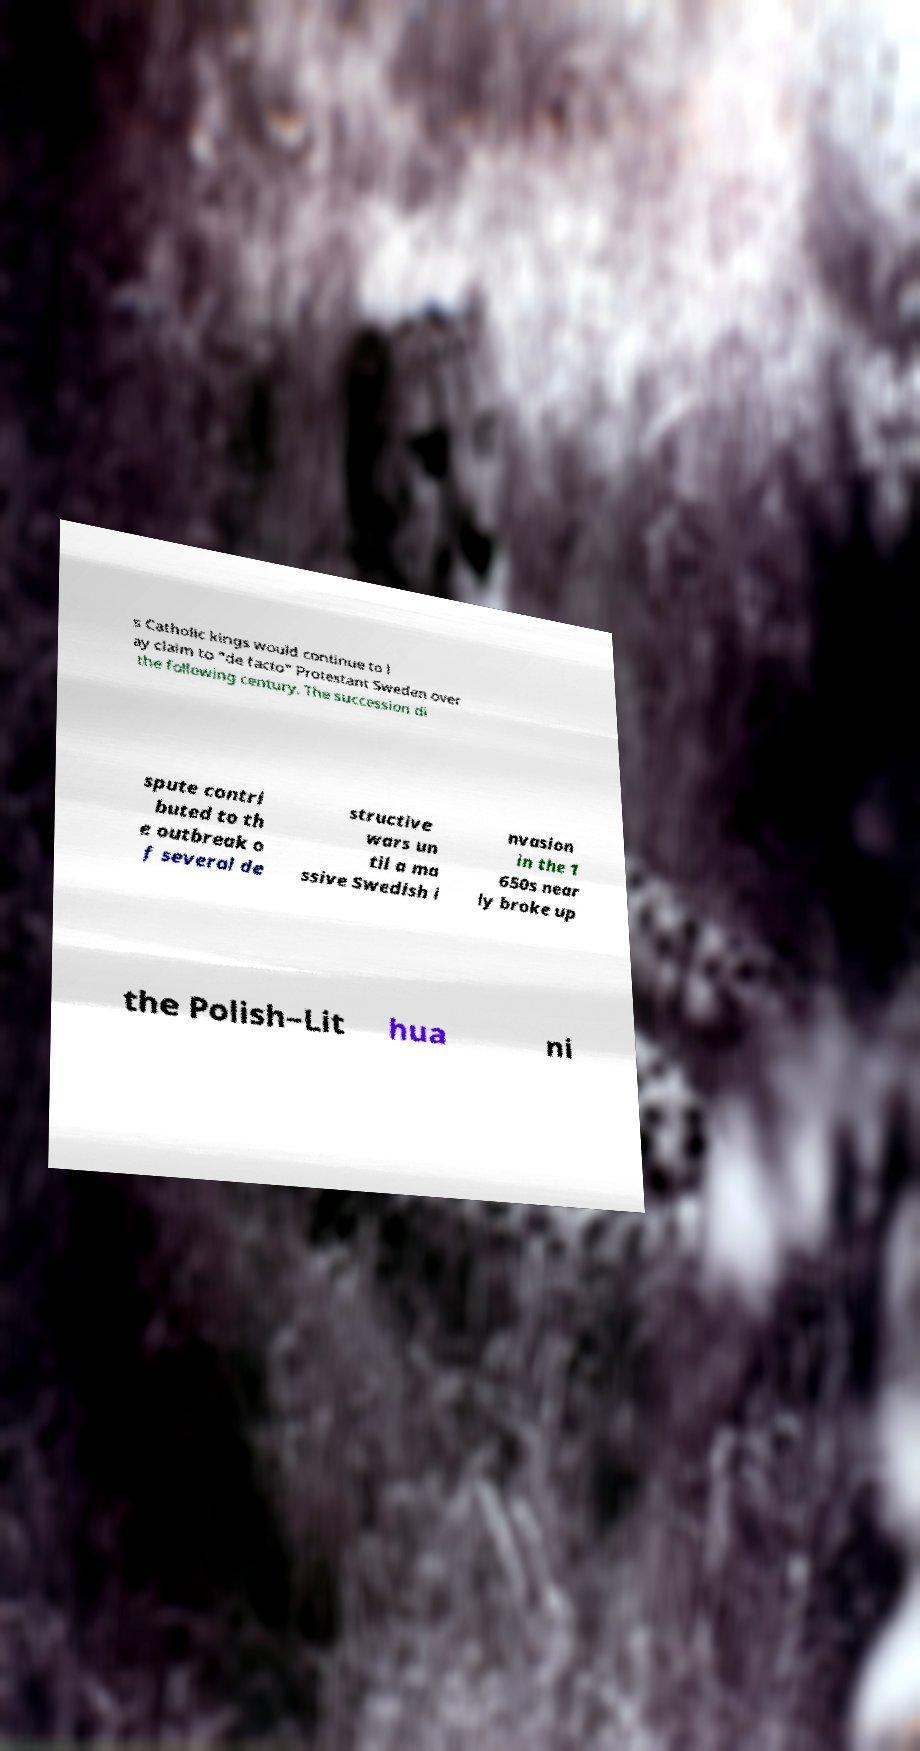Please read and relay the text visible in this image. What does it say? s Catholic kings would continue to l ay claim to "de facto" Protestant Sweden over the following century. The succession di spute contri buted to th e outbreak o f several de structive wars un til a ma ssive Swedish i nvasion in the 1 650s near ly broke up the Polish–Lit hua ni 